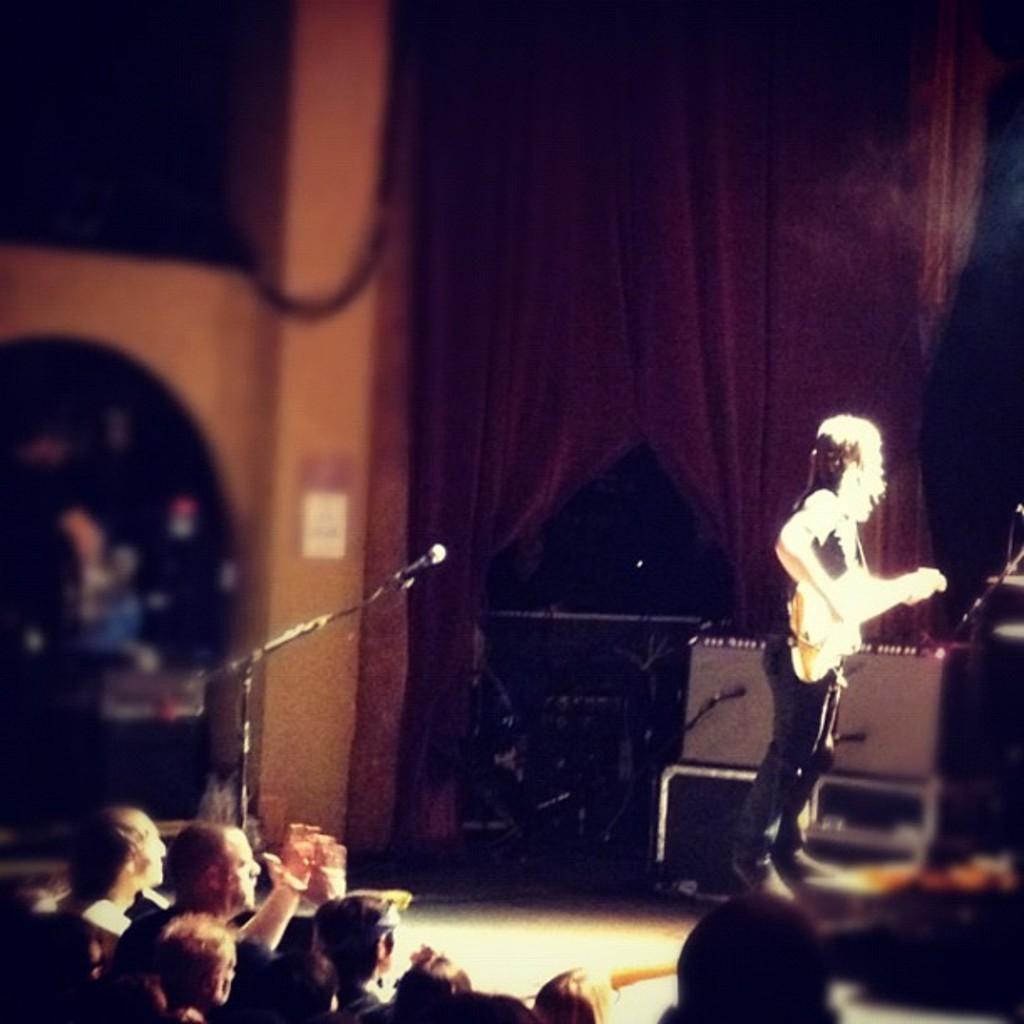Could you give a brief overview of what you see in this image? The image looks like it is clicked in a concert. To the right, the person is standing and playing the guitar. At the bottom there is a crowd, listening and watching to a singer. At the background there is curtain, wall. 